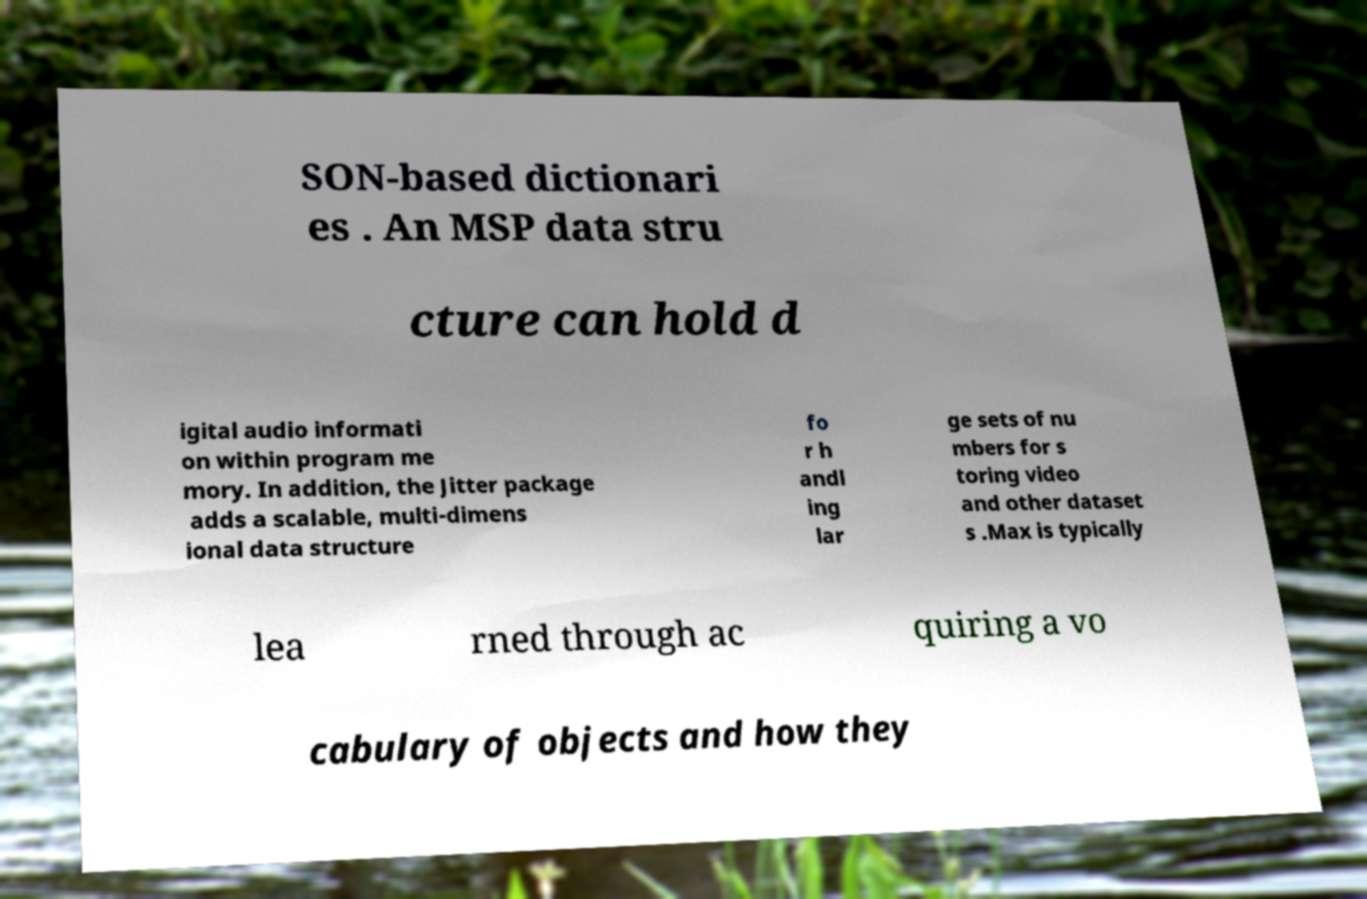Can you accurately transcribe the text from the provided image for me? SON-based dictionari es . An MSP data stru cture can hold d igital audio informati on within program me mory. In addition, the Jitter package adds a scalable, multi-dimens ional data structure fo r h andl ing lar ge sets of nu mbers for s toring video and other dataset s .Max is typically lea rned through ac quiring a vo cabulary of objects and how they 